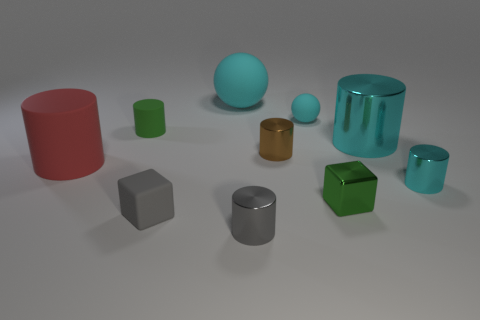There is a small green metal thing; does it have the same shape as the cyan matte thing right of the small gray shiny object?
Give a very brief answer. No. What material is the ball that is to the right of the big thing that is behind the cyan cylinder that is behind the tiny cyan metal thing made of?
Offer a very short reply. Rubber. Is there a cyan ball that has the same size as the green cylinder?
Make the answer very short. Yes. There is a cyan thing that is made of the same material as the big cyan cylinder; what size is it?
Offer a terse response. Small. What is the shape of the brown thing?
Offer a very short reply. Cylinder. Do the green block and the cylinder on the left side of the small green rubber cylinder have the same material?
Keep it short and to the point. No. What number of things are either green cylinders or tiny green metal things?
Your answer should be very brief. 2. Is there a tiny rubber cylinder?
Your response must be concise. Yes. The tiny brown object that is on the right side of the matte cylinder that is in front of the tiny brown metallic thing is what shape?
Ensure brevity in your answer.  Cylinder. What number of things are cylinders behind the big red rubber cylinder or shiny things in front of the large rubber cylinder?
Keep it short and to the point. 6. 